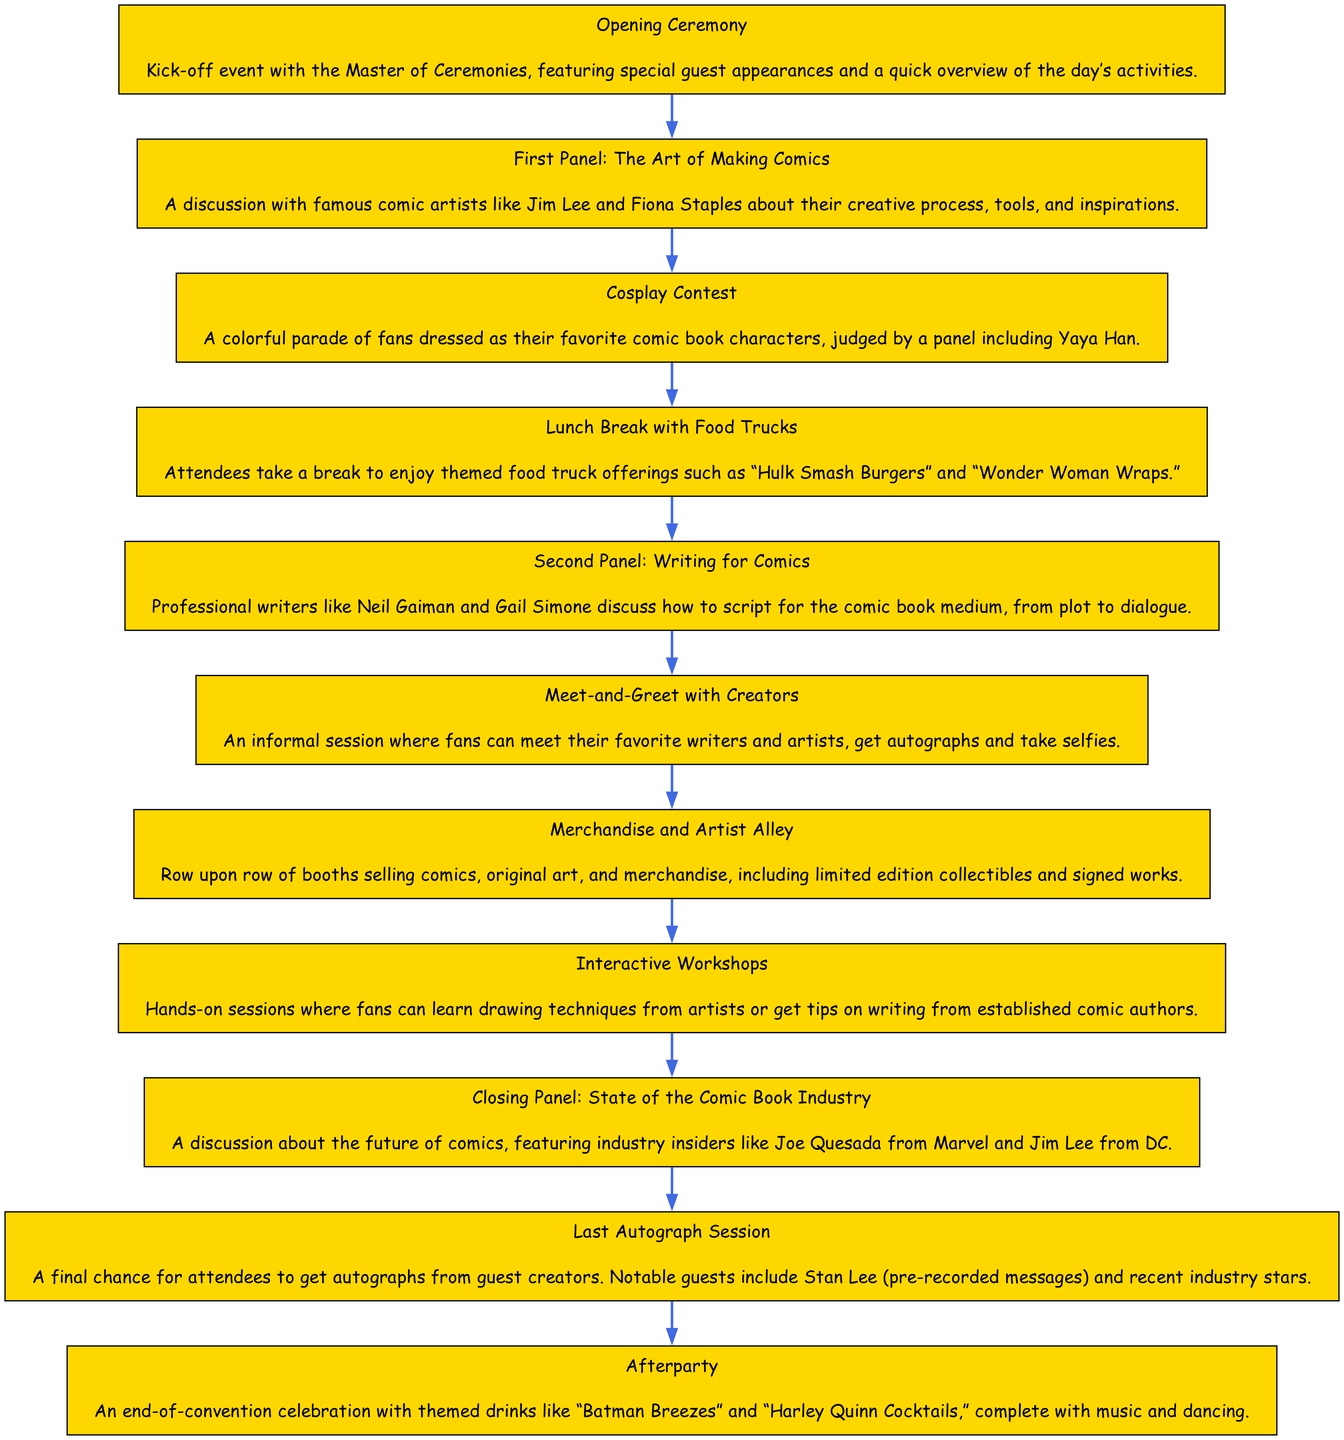What is the first event listed in the timeline? The first event in the timeline is identified as the "Opening Ceremony," which serves as the kick-off event for the convention.
Answer: Opening Ceremony How many panels are included in the timeline? There are three panels listed in the timeline: the first panel focusing on "The Art of Making Comics," the second panel on "Writing for Comics," and the closing panel on "State of the Comic Book Industry."
Answer: 3 Which event comes before the "Cosplay Contest"? The "First Panel: The Art of Making Comics" occurs immediately before the "Cosplay Contest" in the timeline, showing the sequence of activities during the convention.
Answer: First Panel: The Art of Making Comics What type of activity is the "Meet-and-Greet with Creators"? The "Meet-and-Greet with Creators" is categorized as an informal session, which allows fans to interact with writers and artists, highlighting its relaxed nature compared to other structured events.
Answer: Informal session Which event mentions specific food offerings? The "Lunch Break with Food Trucks" event describes themed food truck offerings, specifically mentioning items like “Hulk Smash Burgers” and “Wonder Woman Wraps,” designed to appeal to attendees.
Answer: Lunch Break with Food Trucks What is the last event listed in the timeline? The last event in the timeline is the "Last Autograph Session," which signifies the final opportunity for convention attendees to collect autographs from guest creators.
Answer: Last Autograph Session Which event features a discussion with industry insiders? The "Closing Panel: State of the Comic Book Industry" includes a discussion featuring industry insiders, such as Joe Quesada from Marvel and Jim Lee from DC, focusing on the future of comics.
Answer: Closing Panel: State of the Comic Book Industry What two elements are connected before the "Afterparty"? The "Last Autograph Session" and the "Afterparty" are the two elements that connect consecutively in the timeline, indicating activities at the end of the convention.
Answer: Last Autograph Session and Afterparty How does the timeline flow from the "First Panel" to "Last Autograph Session"? The flow begins with the "First Panel: The Art of Making Comics," followed by the "Cosplay Contest," "Lunch Break with Food Trucks," "Second Panel: Writing for Comics," then the "Meet-and-Greet with Creators," followed by "Merchandise and Artist Alley," "Interactive Workshops," leading finally to the "Last Autograph Session."
Answer: Stepwise sequence of events 